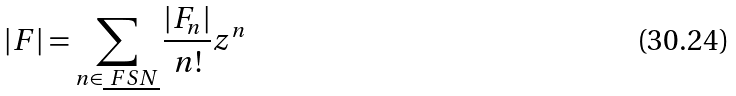Convert formula to latex. <formula><loc_0><loc_0><loc_500><loc_500>| F | = \sum _ { n \in \underline { \ F S N } } \frac { | F _ { n } | } { n ! } z ^ { n }</formula> 